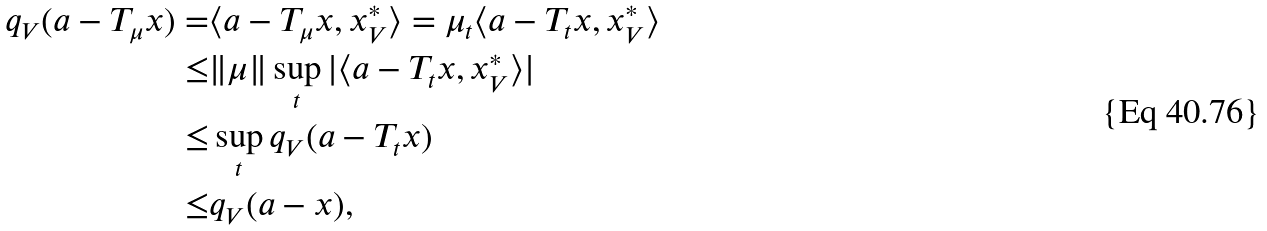<formula> <loc_0><loc_0><loc_500><loc_500>q _ { V } ( a - T _ { \mu } x ) = & \langle a - T _ { \mu } x , x ^ { * } _ { V } \rangle = \mu _ { t } \langle a - T _ { t } x , x ^ { * } _ { V } \rangle \\ \leq & \| \mu \| \sup _ { t } | \langle a - T _ { t } x , x ^ { * } _ { V } \rangle | \\ \leq & \sup _ { t } q _ { V } ( a - T _ { t } x ) \\ \leq & q _ { V } ( a - x ) ,</formula> 